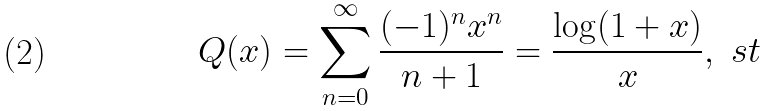Convert formula to latex. <formula><loc_0><loc_0><loc_500><loc_500>Q ( x ) = \sum _ { n = 0 } ^ { \infty } \frac { ( - 1 ) ^ { n } x ^ { n } } { n + 1 } = \frac { \log ( 1 + x ) } { x } , \ s t</formula> 